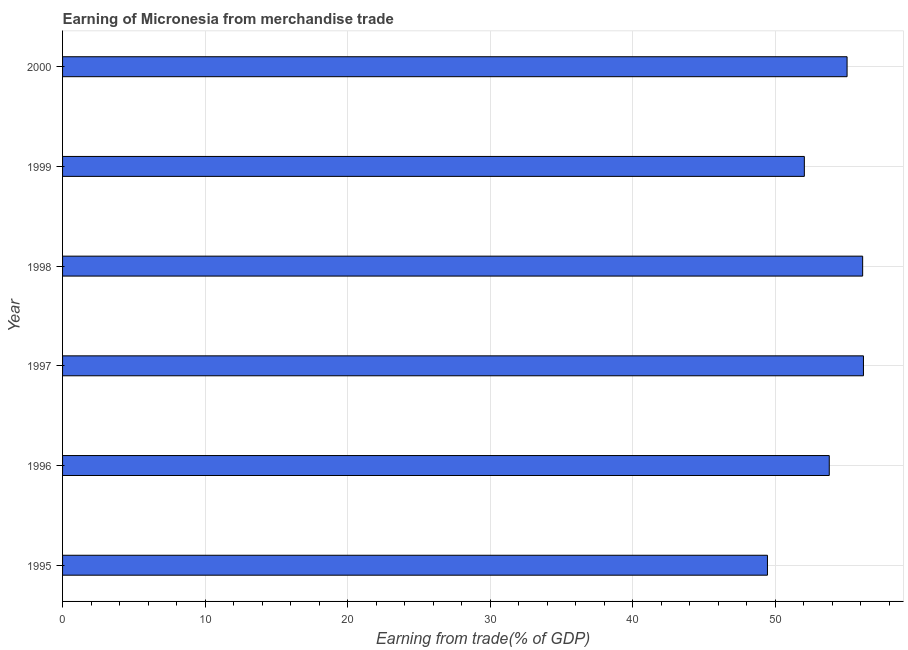Does the graph contain grids?
Your response must be concise. Yes. What is the title of the graph?
Provide a short and direct response. Earning of Micronesia from merchandise trade. What is the label or title of the X-axis?
Keep it short and to the point. Earning from trade(% of GDP). What is the label or title of the Y-axis?
Your answer should be very brief. Year. What is the earning from merchandise trade in 1999?
Your response must be concise. 52.04. Across all years, what is the maximum earning from merchandise trade?
Make the answer very short. 56.19. Across all years, what is the minimum earning from merchandise trade?
Your response must be concise. 49.45. In which year was the earning from merchandise trade maximum?
Your answer should be very brief. 1997. In which year was the earning from merchandise trade minimum?
Offer a terse response. 1995. What is the sum of the earning from merchandise trade?
Keep it short and to the point. 322.64. What is the difference between the earning from merchandise trade in 1995 and 1999?
Ensure brevity in your answer.  -2.59. What is the average earning from merchandise trade per year?
Keep it short and to the point. 53.77. What is the median earning from merchandise trade?
Your answer should be compact. 54.41. In how many years, is the earning from merchandise trade greater than 32 %?
Provide a succinct answer. 6. Is the earning from merchandise trade in 1996 less than that in 2000?
Offer a very short reply. Yes. What is the difference between the highest and the second highest earning from merchandise trade?
Provide a succinct answer. 0.06. What is the difference between the highest and the lowest earning from merchandise trade?
Make the answer very short. 6.73. Are all the bars in the graph horizontal?
Provide a succinct answer. Yes. What is the difference between two consecutive major ticks on the X-axis?
Offer a terse response. 10. Are the values on the major ticks of X-axis written in scientific E-notation?
Offer a very short reply. No. What is the Earning from trade(% of GDP) in 1995?
Offer a terse response. 49.45. What is the Earning from trade(% of GDP) in 1996?
Make the answer very short. 53.79. What is the Earning from trade(% of GDP) in 1997?
Ensure brevity in your answer.  56.19. What is the Earning from trade(% of GDP) in 1998?
Give a very brief answer. 56.13. What is the Earning from trade(% of GDP) in 1999?
Offer a very short reply. 52.04. What is the Earning from trade(% of GDP) in 2000?
Make the answer very short. 55.04. What is the difference between the Earning from trade(% of GDP) in 1995 and 1996?
Your response must be concise. -4.34. What is the difference between the Earning from trade(% of GDP) in 1995 and 1997?
Your answer should be very brief. -6.73. What is the difference between the Earning from trade(% of GDP) in 1995 and 1998?
Ensure brevity in your answer.  -6.68. What is the difference between the Earning from trade(% of GDP) in 1995 and 1999?
Ensure brevity in your answer.  -2.59. What is the difference between the Earning from trade(% of GDP) in 1995 and 2000?
Your answer should be very brief. -5.59. What is the difference between the Earning from trade(% of GDP) in 1996 and 1997?
Offer a terse response. -2.4. What is the difference between the Earning from trade(% of GDP) in 1996 and 1998?
Your response must be concise. -2.34. What is the difference between the Earning from trade(% of GDP) in 1996 and 1999?
Your response must be concise. 1.75. What is the difference between the Earning from trade(% of GDP) in 1996 and 2000?
Give a very brief answer. -1.25. What is the difference between the Earning from trade(% of GDP) in 1997 and 1998?
Provide a short and direct response. 0.06. What is the difference between the Earning from trade(% of GDP) in 1997 and 1999?
Your response must be concise. 4.15. What is the difference between the Earning from trade(% of GDP) in 1997 and 2000?
Give a very brief answer. 1.15. What is the difference between the Earning from trade(% of GDP) in 1998 and 1999?
Offer a terse response. 4.09. What is the difference between the Earning from trade(% of GDP) in 1998 and 2000?
Keep it short and to the point. 1.09. What is the difference between the Earning from trade(% of GDP) in 1999 and 2000?
Offer a very short reply. -3. What is the ratio of the Earning from trade(% of GDP) in 1995 to that in 1996?
Provide a succinct answer. 0.92. What is the ratio of the Earning from trade(% of GDP) in 1995 to that in 1997?
Offer a very short reply. 0.88. What is the ratio of the Earning from trade(% of GDP) in 1995 to that in 1998?
Your response must be concise. 0.88. What is the ratio of the Earning from trade(% of GDP) in 1995 to that in 2000?
Offer a very short reply. 0.9. What is the ratio of the Earning from trade(% of GDP) in 1996 to that in 1997?
Provide a short and direct response. 0.96. What is the ratio of the Earning from trade(% of GDP) in 1996 to that in 1998?
Provide a short and direct response. 0.96. What is the ratio of the Earning from trade(% of GDP) in 1996 to that in 1999?
Give a very brief answer. 1.03. What is the ratio of the Earning from trade(% of GDP) in 1996 to that in 2000?
Make the answer very short. 0.98. What is the ratio of the Earning from trade(% of GDP) in 1997 to that in 1999?
Provide a short and direct response. 1.08. What is the ratio of the Earning from trade(% of GDP) in 1997 to that in 2000?
Keep it short and to the point. 1.02. What is the ratio of the Earning from trade(% of GDP) in 1998 to that in 1999?
Offer a very short reply. 1.08. What is the ratio of the Earning from trade(% of GDP) in 1999 to that in 2000?
Your answer should be compact. 0.95. 